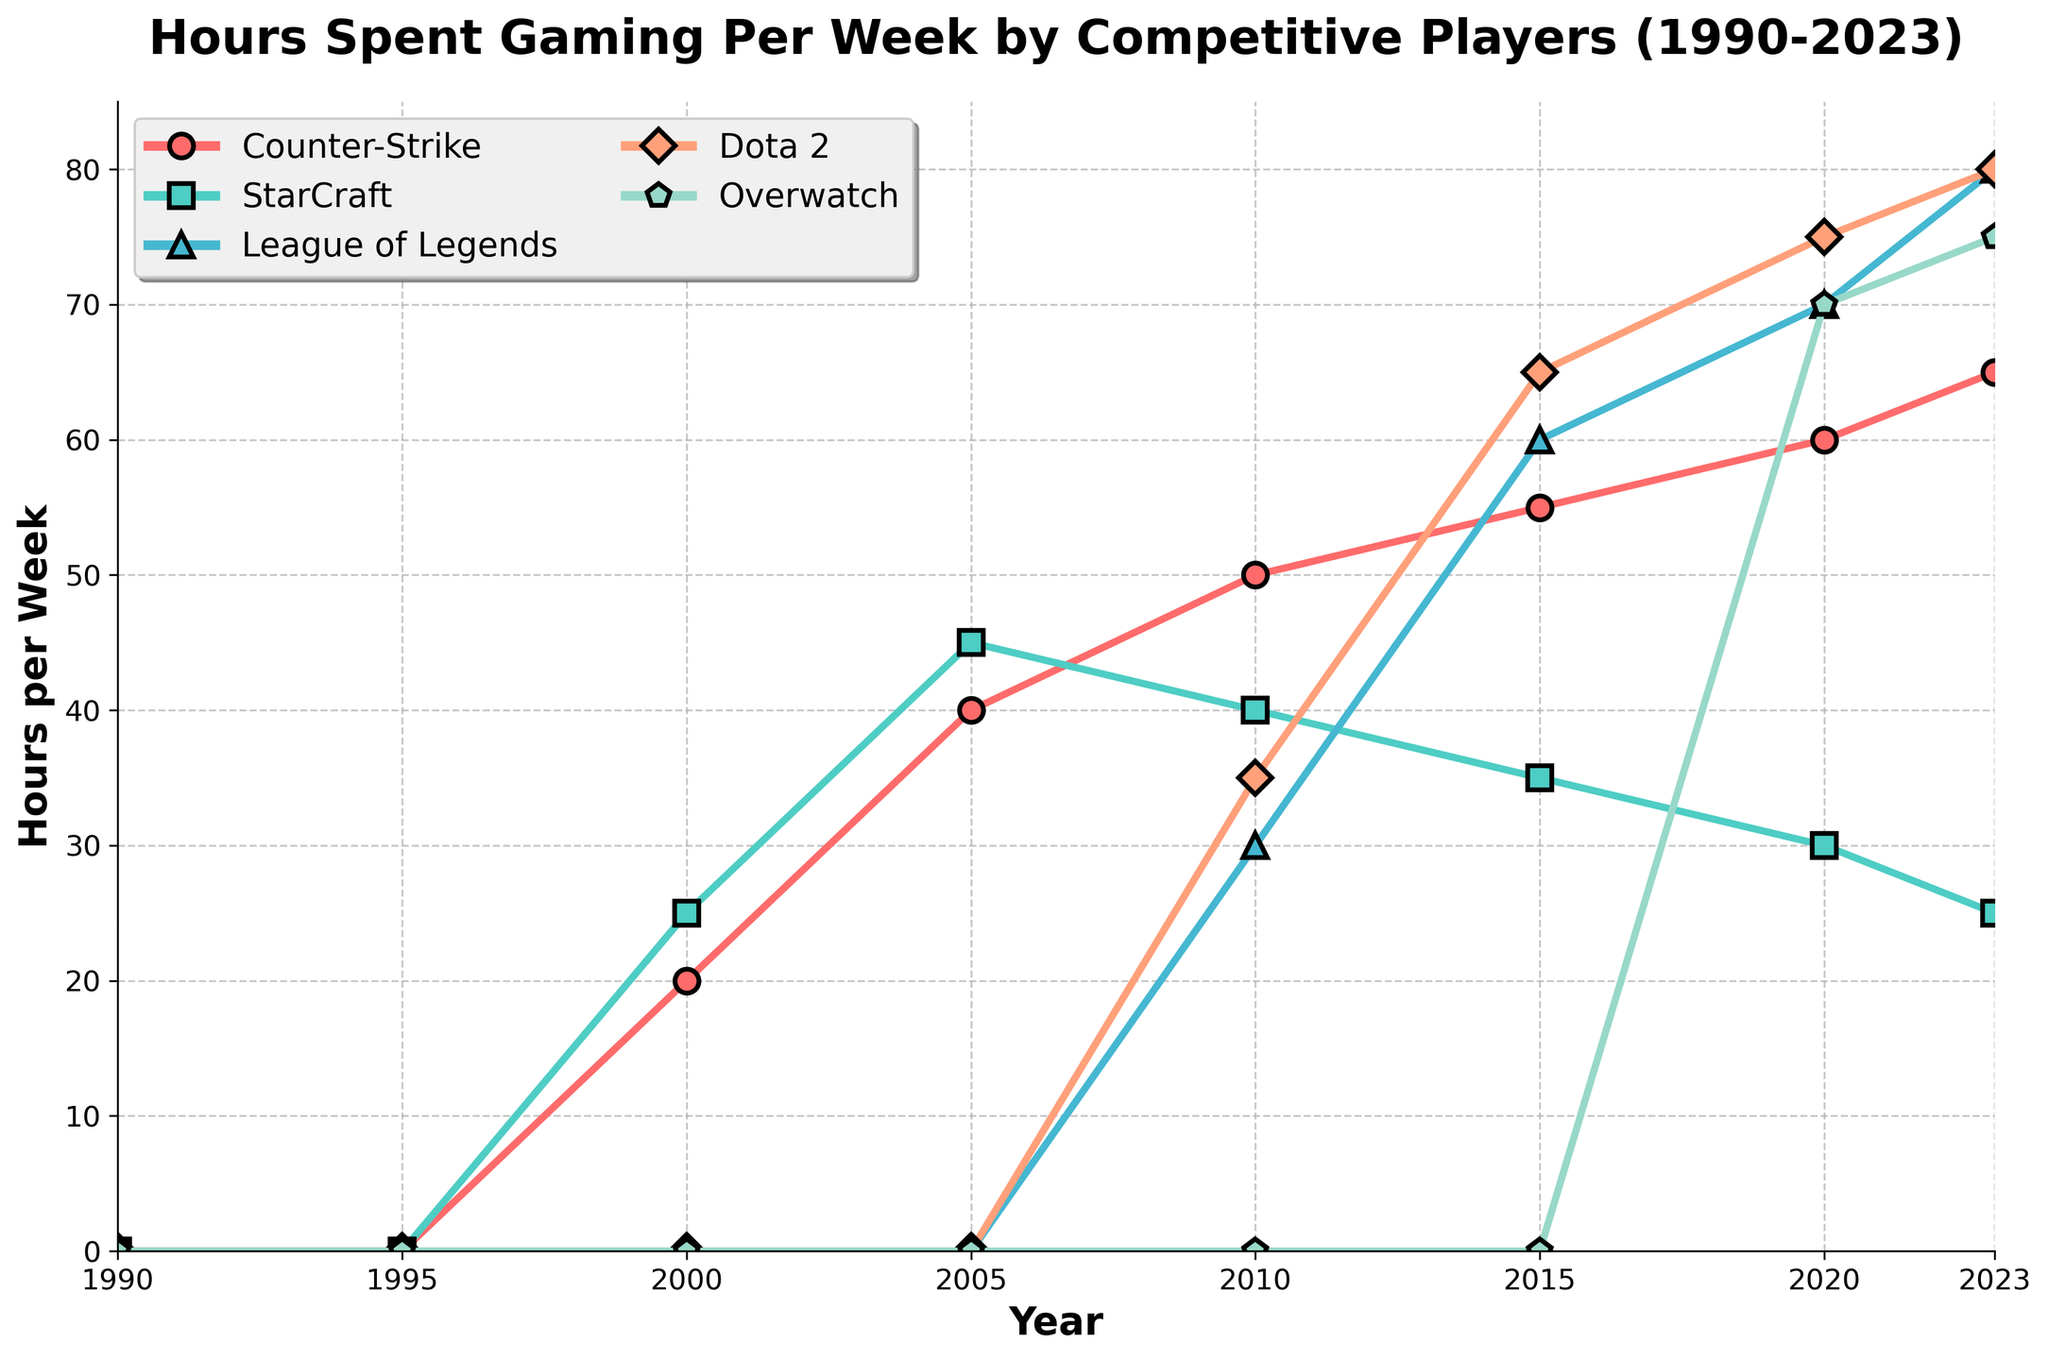What was the first year where any game had recorded hours spent gaming? The first year where hours spent gaming were recorded is when the value for any game is greater than 0. For Counter-Strike and StarCraft, recorded hours first appear in 2000. This is evident as the values for Counter-Strike and StarCraft in 2000 are 20 and 25 hours, respectively.
Answer: 2000 Which game had the highest increase in hours spent gaming between 2000 and 2023? To determine the game with the highest increase, we need to look at the hours spent in 2000 and 2023 for each game and calculate the difference. The differences are as follows: Counter-Strike (65 - 20 = 45), StarCraft (25 - 25 = 0), League of Legends (80 - 0 = 80), Dota 2 (80 - 0 = 80), and Overwatch (75 - 0 = 75). The highest increase is for both League of Legends and Dota 2 at 80 hours.
Answer: League of Legends and Dota 2 By how much did the hours spent gaming for League of Legends change from 2010 to 2023? The change in hours spent gaming from 2010 to 2023 is calculated by subtracting the value in 2010 from the value in 2023. For League of Legends, the values are 30 in 2010 and 80 in 2023. Therefore, the change is 80 - 30 = 50 hours.
Answer: 50 In which year did Overwatch first appear in the data? Overwatch first appears in the data when the value is greater than 0. The first year we see hours recorded for Overwatch is in 2020 with 70 hours.
Answer: 2020 Which game had the least variation in hours spent gaming from 2010 to 2023? To find the game with the least variation, examine the change in hours spent for each game from 2010 to 2023. StarCraft had hours of 40 in 2010 and 25 in 2023, a change of 15 hours. This is the smallest change compared to other games where changes exceeded 15 hours.
Answer: StarCraft What are the total hours spent gaming for Counter-Strike across all recorded years? Sum the hours for Counter-Strike from 2000 to 2023. The values are 20, 40, 50, 55, 60, and 65. The sum is 20 + 40 + 50 + 55 + 60 + 65 = 290 hours.
Answer: 290 Which game had the steepest increase in hours between 2015 and 2020? To determine the steepest increase, subtract the 2015 values from the 2020 values for each game and compare. Increases are: Counter-Strike (60 - 55 = 5), StarCraft (30 - 35 = -5), League of Legends (70 - 60 = 10), Dota 2 (75 - 65 = 10), Overwatch (70 - 0 = 70). The steepest increase is for Overwatch with 70 hours.
Answer: Overwatch How did hours spent gaming for Dota 2 change from 2010 to 2023? Subtract the value in 2010 from the value in 2023 for Dota 2. The values are 35 in 2010 and 80 in 2023. Therefore, the change is 80 - 35 = 45 hours.
Answer: 45 